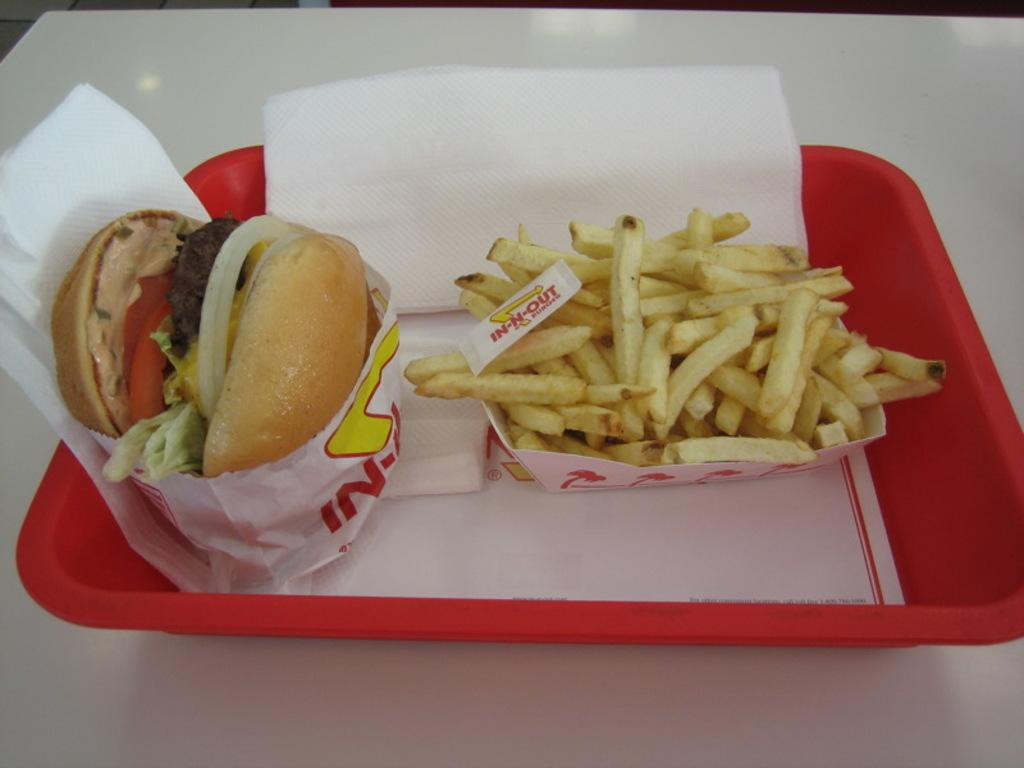What color is the table in the image? The table in the image is white. What is on the table in the image? There is a red tray on the table. What food items are on the tray? The tray contains a burger and french fries. What else is on the tray besides food? There are tissue papers on the tray. How does the man on the tray enjoy the quiet atmosphere while eating the burger? There is no man present on the tray or in the image. The tray contains a burger, french fries, and tissue papers. 